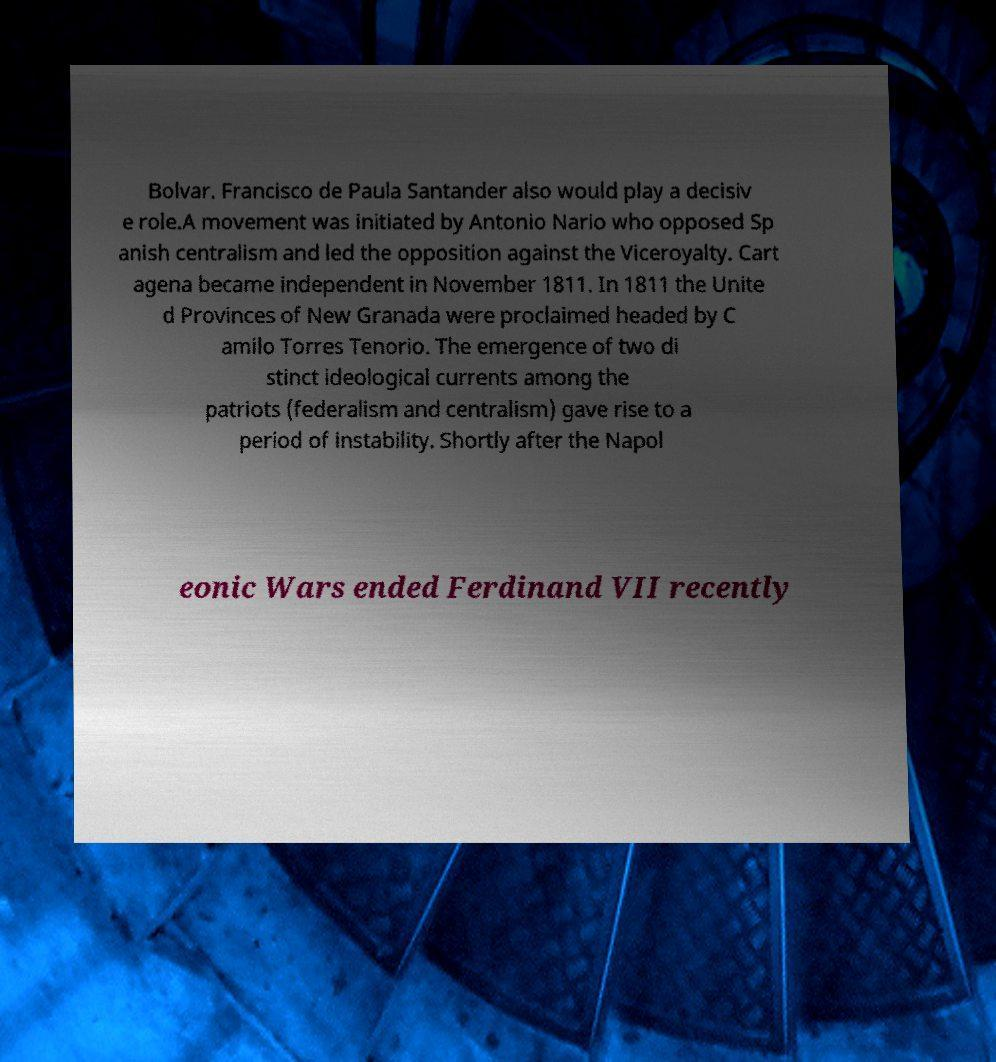I need the written content from this picture converted into text. Can you do that? Bolvar. Francisco de Paula Santander also would play a decisiv e role.A movement was initiated by Antonio Nario who opposed Sp anish centralism and led the opposition against the Viceroyalty. Cart agena became independent in November 1811. In 1811 the Unite d Provinces of New Granada were proclaimed headed by C amilo Torres Tenorio. The emergence of two di stinct ideological currents among the patriots (federalism and centralism) gave rise to a period of instability. Shortly after the Napol eonic Wars ended Ferdinand VII recently 